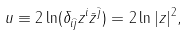Convert formula to latex. <formula><loc_0><loc_0><loc_500><loc_500>u \equiv 2 \ln ( \delta _ { i \bar { j } } z ^ { i } \bar { z } ^ { \bar { j } } ) = 2 \ln | z | ^ { 2 } ,</formula> 